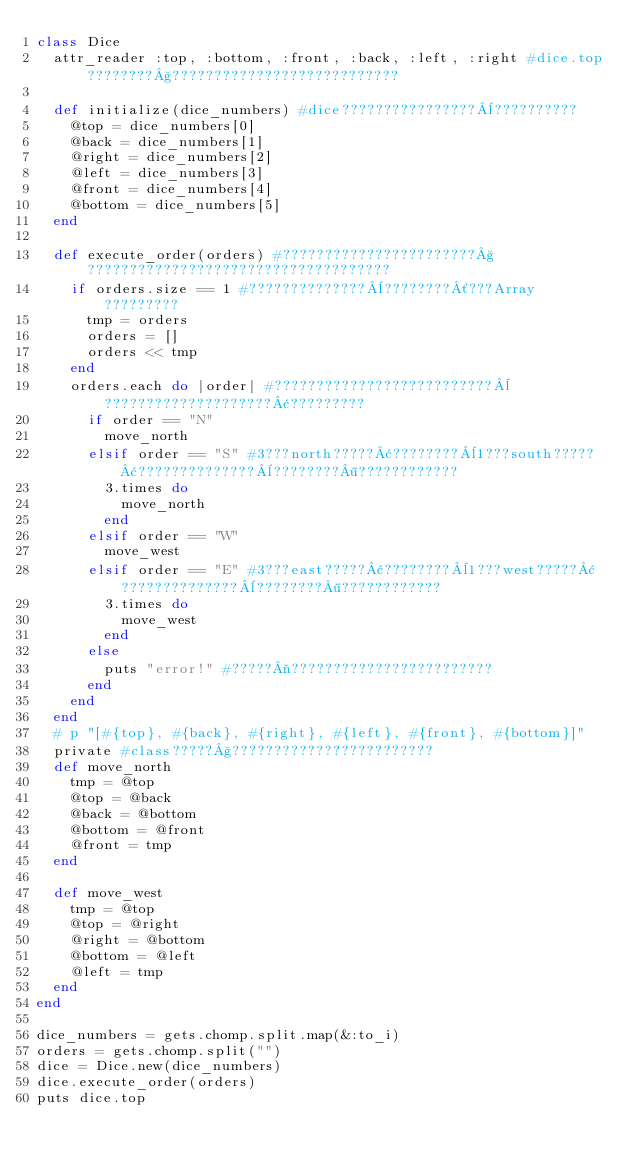Convert code to text. <code><loc_0><loc_0><loc_500><loc_500><_Ruby_>class Dice
  attr_reader :top, :bottom, :front, :back, :left, :right #dice.top????????§???????????????????????????

  def initialize(dice_numbers) #dice????????????????¨??????????
    @top = dice_numbers[0]
    @back = dice_numbers[1]
    @right = dice_numbers[2]
    @left = dice_numbers[3]
    @front = dice_numbers[4]
    @bottom = dice_numbers[5]
  end

  def execute_order(orders) #???????????????????????§????????????????????????????????????
    if orders.size == 1 #??????????????¨????????´???Array?????????
      tmp = orders
      orders = []
      orders << tmp
    end
    orders.each do |order| #??????????????????????????¨????????????????????¢?????????
      if order == "N"
        move_north
      elsif order == "S" #3???north?????¢????????¨1???south?????¢??????????????¨????????¶????????????
        3.times do
          move_north
        end
      elsif order == "W"
        move_west
      elsif order == "E" #3???east?????¢????????¨1???west?????¢??????????????¨????????¶????????????
        3.times do
          move_west
        end
      else
        puts "error!" #?????¬????????????????????????
      end
    end
  end
  # p "[#{top}, #{back}, #{right}, #{left}, #{front}, #{bottom}]"
  private #class?????§????????????????????????
  def move_north
    tmp = @top
    @top = @back
    @back = @bottom
    @bottom = @front
    @front = tmp
  end

  def move_west
    tmp = @top
    @top = @right
    @right = @bottom
    @bottom = @left
    @left = tmp
  end
end

dice_numbers = gets.chomp.split.map(&:to_i)
orders = gets.chomp.split("")
dice = Dice.new(dice_numbers)
dice.execute_order(orders)
puts dice.top</code> 